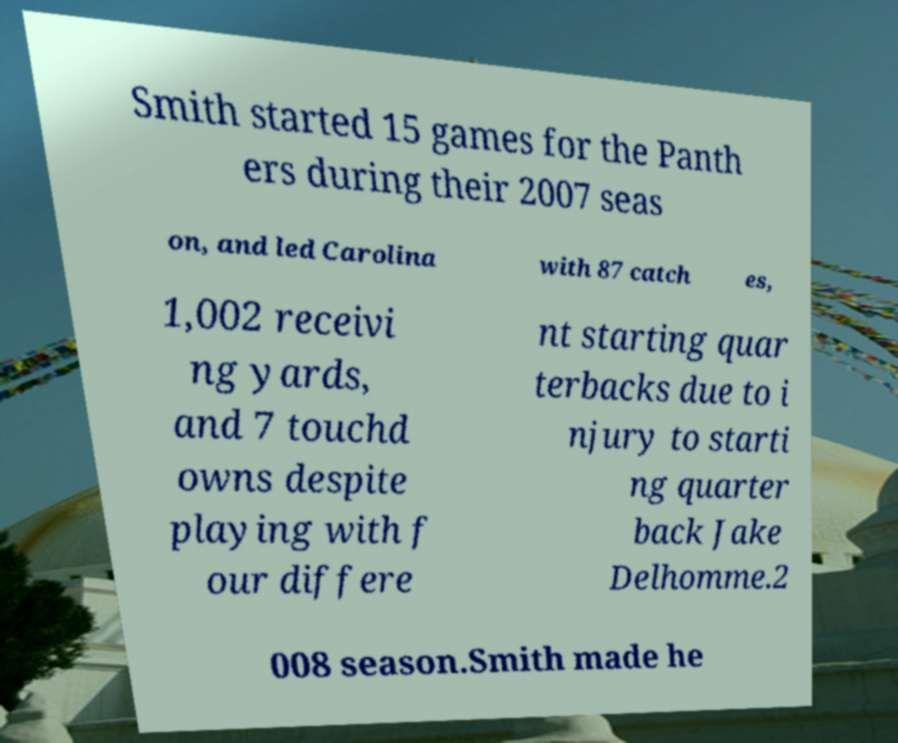Please identify and transcribe the text found in this image. Smith started 15 games for the Panth ers during their 2007 seas on, and led Carolina with 87 catch es, 1,002 receivi ng yards, and 7 touchd owns despite playing with f our differe nt starting quar terbacks due to i njury to starti ng quarter back Jake Delhomme.2 008 season.Smith made he 